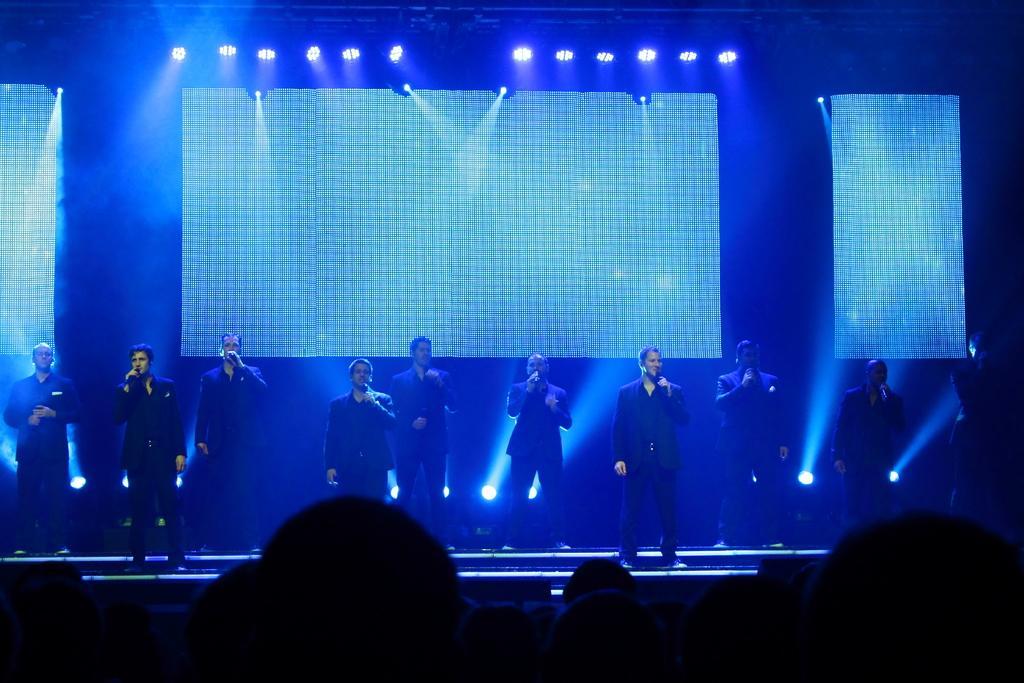Describe this image in one or two sentences. In this picture we can see a group of people where some are standing on stage and holding mics with their hands and in the background we can see lights. 